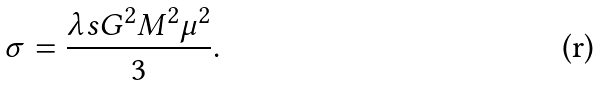Convert formula to latex. <formula><loc_0><loc_0><loc_500><loc_500>\sigma = \frac { \lambda s G ^ { 2 } M ^ { 2 } \mu ^ { 2 } } { 3 } .</formula> 